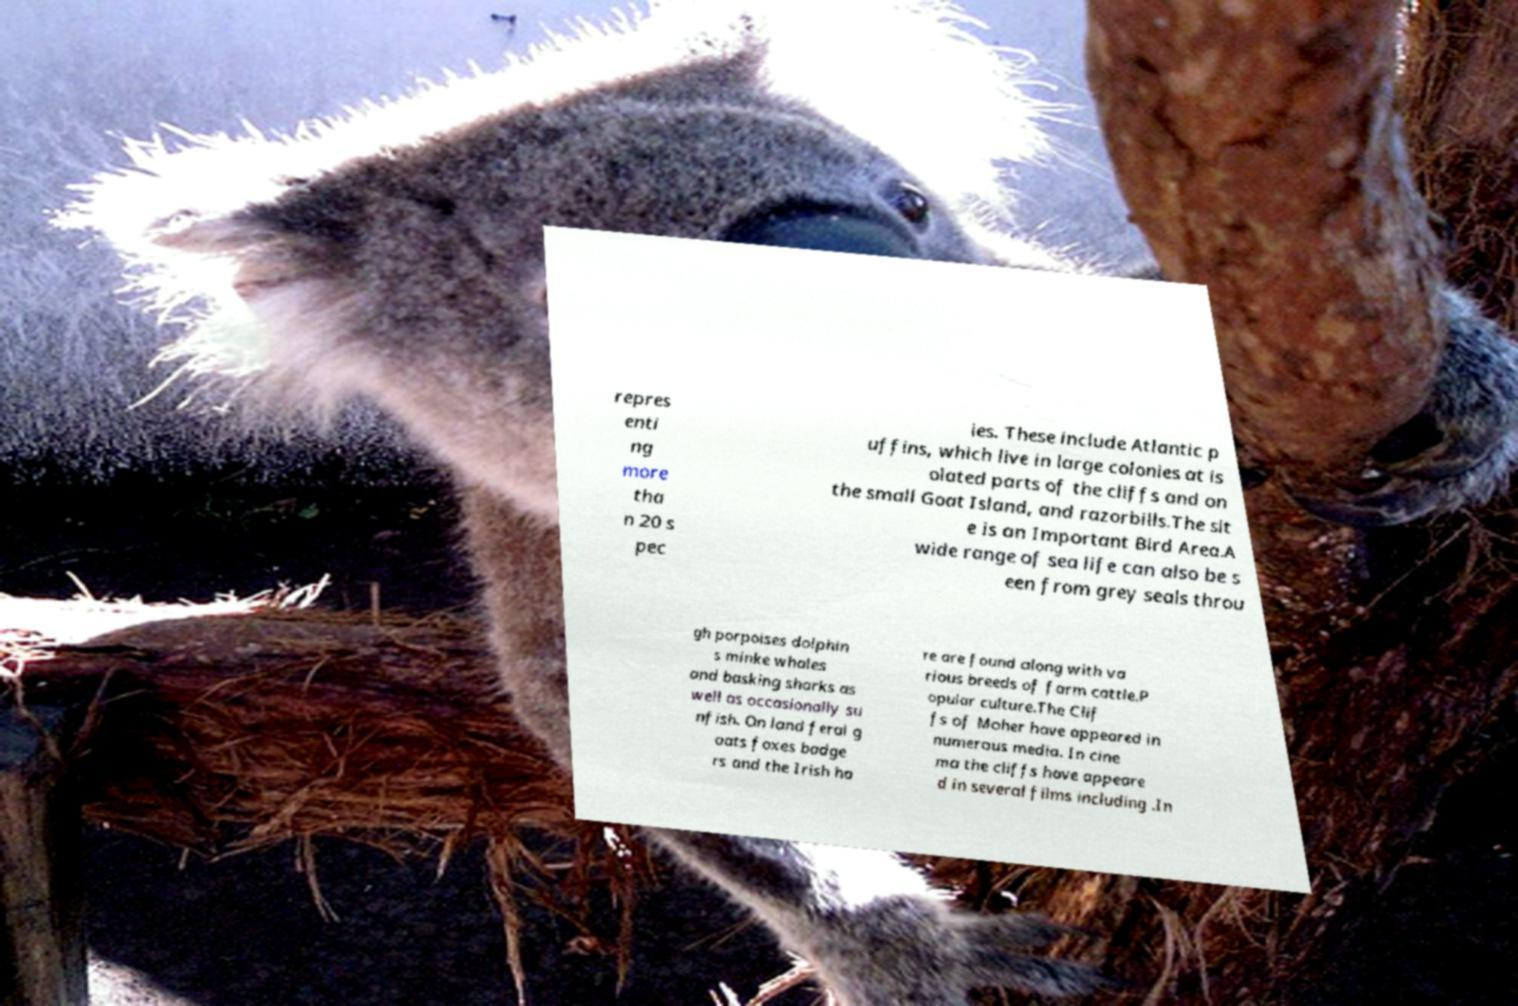Can you accurately transcribe the text from the provided image for me? repres enti ng more tha n 20 s pec ies. These include Atlantic p uffins, which live in large colonies at is olated parts of the cliffs and on the small Goat Island, and razorbills.The sit e is an Important Bird Area.A wide range of sea life can also be s een from grey seals throu gh porpoises dolphin s minke whales and basking sharks as well as occasionally su nfish. On land feral g oats foxes badge rs and the Irish ha re are found along with va rious breeds of farm cattle.P opular culture.The Clif fs of Moher have appeared in numerous media. In cine ma the cliffs have appeare d in several films including .In 